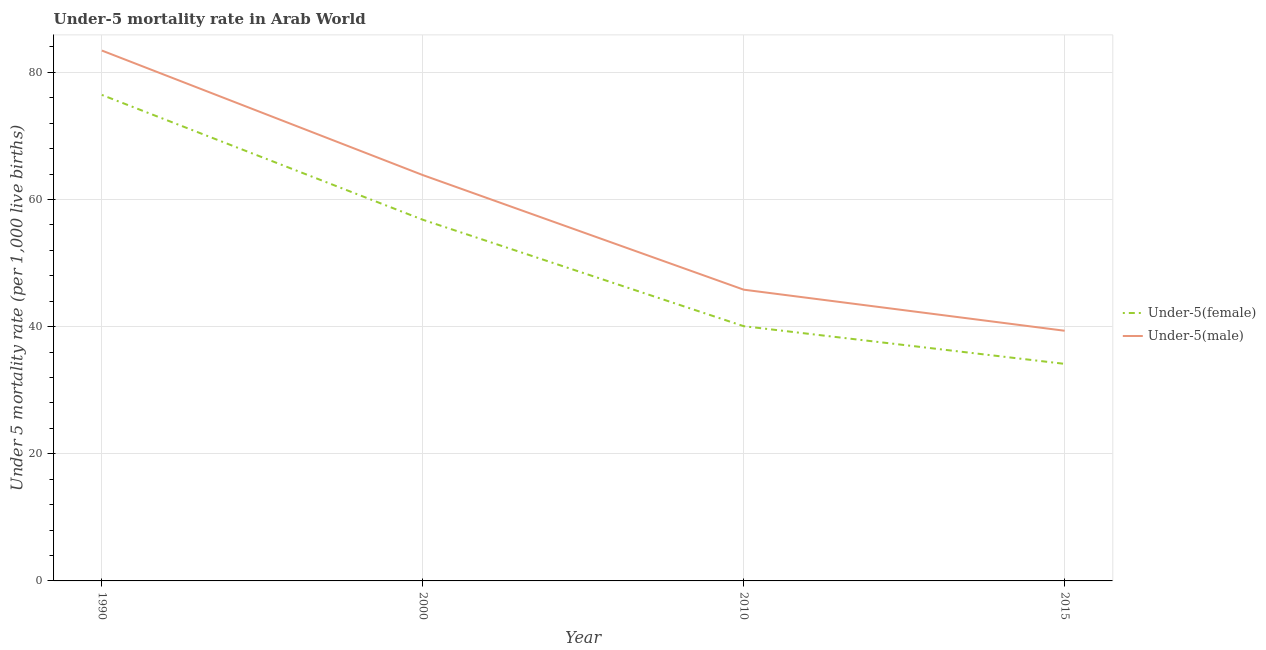How many different coloured lines are there?
Offer a terse response. 2. What is the under-5 female mortality rate in 2010?
Your answer should be very brief. 40.06. Across all years, what is the maximum under-5 male mortality rate?
Offer a terse response. 83.42. Across all years, what is the minimum under-5 female mortality rate?
Provide a succinct answer. 34.14. In which year was the under-5 male mortality rate minimum?
Ensure brevity in your answer.  2015. What is the total under-5 female mortality rate in the graph?
Give a very brief answer. 207.45. What is the difference between the under-5 female mortality rate in 2010 and that in 2015?
Provide a short and direct response. 5.93. What is the difference between the under-5 male mortality rate in 2000 and the under-5 female mortality rate in 1990?
Your response must be concise. -12.61. What is the average under-5 female mortality rate per year?
Offer a very short reply. 51.86. In the year 1990, what is the difference between the under-5 female mortality rate and under-5 male mortality rate?
Make the answer very short. -6.98. In how many years, is the under-5 male mortality rate greater than 76?
Keep it short and to the point. 1. What is the ratio of the under-5 female mortality rate in 2010 to that in 2015?
Your answer should be very brief. 1.17. Is the difference between the under-5 female mortality rate in 2000 and 2015 greater than the difference between the under-5 male mortality rate in 2000 and 2015?
Ensure brevity in your answer.  No. What is the difference between the highest and the second highest under-5 female mortality rate?
Your answer should be very brief. 19.63. What is the difference between the highest and the lowest under-5 male mortality rate?
Keep it short and to the point. 44.07. Does the under-5 female mortality rate monotonically increase over the years?
Your answer should be compact. No. Is the under-5 female mortality rate strictly greater than the under-5 male mortality rate over the years?
Your response must be concise. No. Is the under-5 female mortality rate strictly less than the under-5 male mortality rate over the years?
Keep it short and to the point. Yes. Where does the legend appear in the graph?
Keep it short and to the point. Center right. What is the title of the graph?
Your answer should be compact. Under-5 mortality rate in Arab World. Does "Domestic Liabilities" appear as one of the legend labels in the graph?
Offer a terse response. No. What is the label or title of the Y-axis?
Provide a short and direct response. Under 5 mortality rate (per 1,0 live births). What is the Under 5 mortality rate (per 1,000 live births) in Under-5(female) in 1990?
Offer a very short reply. 76.44. What is the Under 5 mortality rate (per 1,000 live births) of Under-5(male) in 1990?
Give a very brief answer. 83.42. What is the Under 5 mortality rate (per 1,000 live births) of Under-5(female) in 2000?
Provide a succinct answer. 56.81. What is the Under 5 mortality rate (per 1,000 live births) of Under-5(male) in 2000?
Provide a short and direct response. 63.83. What is the Under 5 mortality rate (per 1,000 live births) in Under-5(female) in 2010?
Provide a short and direct response. 40.06. What is the Under 5 mortality rate (per 1,000 live births) in Under-5(male) in 2010?
Your answer should be compact. 45.81. What is the Under 5 mortality rate (per 1,000 live births) of Under-5(female) in 2015?
Your answer should be very brief. 34.14. What is the Under 5 mortality rate (per 1,000 live births) in Under-5(male) in 2015?
Give a very brief answer. 39.35. Across all years, what is the maximum Under 5 mortality rate (per 1,000 live births) in Under-5(female)?
Make the answer very short. 76.44. Across all years, what is the maximum Under 5 mortality rate (per 1,000 live births) in Under-5(male)?
Provide a succinct answer. 83.42. Across all years, what is the minimum Under 5 mortality rate (per 1,000 live births) in Under-5(female)?
Ensure brevity in your answer.  34.14. Across all years, what is the minimum Under 5 mortality rate (per 1,000 live births) of Under-5(male)?
Give a very brief answer. 39.35. What is the total Under 5 mortality rate (per 1,000 live births) of Under-5(female) in the graph?
Ensure brevity in your answer.  207.45. What is the total Under 5 mortality rate (per 1,000 live births) in Under-5(male) in the graph?
Offer a very short reply. 232.4. What is the difference between the Under 5 mortality rate (per 1,000 live births) of Under-5(female) in 1990 and that in 2000?
Your response must be concise. 19.63. What is the difference between the Under 5 mortality rate (per 1,000 live births) of Under-5(male) in 1990 and that in 2000?
Give a very brief answer. 19.59. What is the difference between the Under 5 mortality rate (per 1,000 live births) in Under-5(female) in 1990 and that in 2010?
Give a very brief answer. 36.38. What is the difference between the Under 5 mortality rate (per 1,000 live births) in Under-5(male) in 1990 and that in 2010?
Give a very brief answer. 37.61. What is the difference between the Under 5 mortality rate (per 1,000 live births) in Under-5(female) in 1990 and that in 2015?
Your response must be concise. 42.3. What is the difference between the Under 5 mortality rate (per 1,000 live births) of Under-5(male) in 1990 and that in 2015?
Your answer should be compact. 44.07. What is the difference between the Under 5 mortality rate (per 1,000 live births) of Under-5(female) in 2000 and that in 2010?
Make the answer very short. 16.74. What is the difference between the Under 5 mortality rate (per 1,000 live births) of Under-5(male) in 2000 and that in 2010?
Your answer should be very brief. 18.03. What is the difference between the Under 5 mortality rate (per 1,000 live births) of Under-5(female) in 2000 and that in 2015?
Offer a very short reply. 22.67. What is the difference between the Under 5 mortality rate (per 1,000 live births) in Under-5(male) in 2000 and that in 2015?
Your response must be concise. 24.49. What is the difference between the Under 5 mortality rate (per 1,000 live births) of Under-5(female) in 2010 and that in 2015?
Offer a terse response. 5.93. What is the difference between the Under 5 mortality rate (per 1,000 live births) of Under-5(male) in 2010 and that in 2015?
Offer a terse response. 6.46. What is the difference between the Under 5 mortality rate (per 1,000 live births) of Under-5(female) in 1990 and the Under 5 mortality rate (per 1,000 live births) of Under-5(male) in 2000?
Your answer should be very brief. 12.61. What is the difference between the Under 5 mortality rate (per 1,000 live births) in Under-5(female) in 1990 and the Under 5 mortality rate (per 1,000 live births) in Under-5(male) in 2010?
Provide a short and direct response. 30.63. What is the difference between the Under 5 mortality rate (per 1,000 live births) in Under-5(female) in 1990 and the Under 5 mortality rate (per 1,000 live births) in Under-5(male) in 2015?
Offer a terse response. 37.09. What is the difference between the Under 5 mortality rate (per 1,000 live births) in Under-5(female) in 2000 and the Under 5 mortality rate (per 1,000 live births) in Under-5(male) in 2010?
Provide a short and direct response. 11. What is the difference between the Under 5 mortality rate (per 1,000 live births) in Under-5(female) in 2000 and the Under 5 mortality rate (per 1,000 live births) in Under-5(male) in 2015?
Ensure brevity in your answer.  17.46. What is the difference between the Under 5 mortality rate (per 1,000 live births) of Under-5(female) in 2010 and the Under 5 mortality rate (per 1,000 live births) of Under-5(male) in 2015?
Provide a succinct answer. 0.72. What is the average Under 5 mortality rate (per 1,000 live births) in Under-5(female) per year?
Provide a short and direct response. 51.86. What is the average Under 5 mortality rate (per 1,000 live births) in Under-5(male) per year?
Make the answer very short. 58.1. In the year 1990, what is the difference between the Under 5 mortality rate (per 1,000 live births) of Under-5(female) and Under 5 mortality rate (per 1,000 live births) of Under-5(male)?
Offer a very short reply. -6.98. In the year 2000, what is the difference between the Under 5 mortality rate (per 1,000 live births) of Under-5(female) and Under 5 mortality rate (per 1,000 live births) of Under-5(male)?
Make the answer very short. -7.02. In the year 2010, what is the difference between the Under 5 mortality rate (per 1,000 live births) of Under-5(female) and Under 5 mortality rate (per 1,000 live births) of Under-5(male)?
Offer a very short reply. -5.74. In the year 2015, what is the difference between the Under 5 mortality rate (per 1,000 live births) in Under-5(female) and Under 5 mortality rate (per 1,000 live births) in Under-5(male)?
Provide a succinct answer. -5.21. What is the ratio of the Under 5 mortality rate (per 1,000 live births) in Under-5(female) in 1990 to that in 2000?
Ensure brevity in your answer.  1.35. What is the ratio of the Under 5 mortality rate (per 1,000 live births) in Under-5(male) in 1990 to that in 2000?
Provide a short and direct response. 1.31. What is the ratio of the Under 5 mortality rate (per 1,000 live births) of Under-5(female) in 1990 to that in 2010?
Offer a very short reply. 1.91. What is the ratio of the Under 5 mortality rate (per 1,000 live births) of Under-5(male) in 1990 to that in 2010?
Ensure brevity in your answer.  1.82. What is the ratio of the Under 5 mortality rate (per 1,000 live births) in Under-5(female) in 1990 to that in 2015?
Keep it short and to the point. 2.24. What is the ratio of the Under 5 mortality rate (per 1,000 live births) of Under-5(male) in 1990 to that in 2015?
Your answer should be very brief. 2.12. What is the ratio of the Under 5 mortality rate (per 1,000 live births) in Under-5(female) in 2000 to that in 2010?
Ensure brevity in your answer.  1.42. What is the ratio of the Under 5 mortality rate (per 1,000 live births) in Under-5(male) in 2000 to that in 2010?
Provide a short and direct response. 1.39. What is the ratio of the Under 5 mortality rate (per 1,000 live births) of Under-5(female) in 2000 to that in 2015?
Make the answer very short. 1.66. What is the ratio of the Under 5 mortality rate (per 1,000 live births) of Under-5(male) in 2000 to that in 2015?
Provide a succinct answer. 1.62. What is the ratio of the Under 5 mortality rate (per 1,000 live births) in Under-5(female) in 2010 to that in 2015?
Your response must be concise. 1.17. What is the ratio of the Under 5 mortality rate (per 1,000 live births) in Under-5(male) in 2010 to that in 2015?
Your answer should be compact. 1.16. What is the difference between the highest and the second highest Under 5 mortality rate (per 1,000 live births) in Under-5(female)?
Offer a very short reply. 19.63. What is the difference between the highest and the second highest Under 5 mortality rate (per 1,000 live births) in Under-5(male)?
Offer a terse response. 19.59. What is the difference between the highest and the lowest Under 5 mortality rate (per 1,000 live births) of Under-5(female)?
Offer a terse response. 42.3. What is the difference between the highest and the lowest Under 5 mortality rate (per 1,000 live births) of Under-5(male)?
Offer a very short reply. 44.07. 